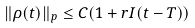<formula> <loc_0><loc_0><loc_500><loc_500>\| \rho ( t ) \| _ { p } \leq C ( 1 + r I ( t - T ) )</formula> 